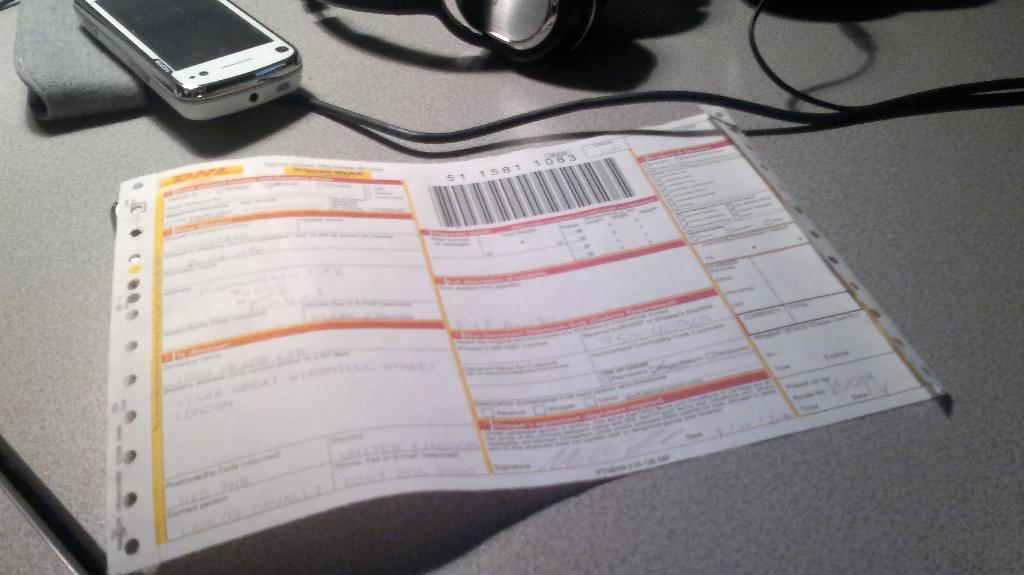What is the primary object featured in the image? There is a paper in the image. What else can be seen in the image besides the paper? There is a mobile and a wire in the image. What is the color or appearance of the surface on which the objects are placed? The objects are on an ash-colored surface in the image. What type of quill is being used to write on the paper in the image? There is no quill present in the image; the paper is not being written on. Can you see a zipper on the mobile in the image? There is no zipper present on the mobile in the image. 